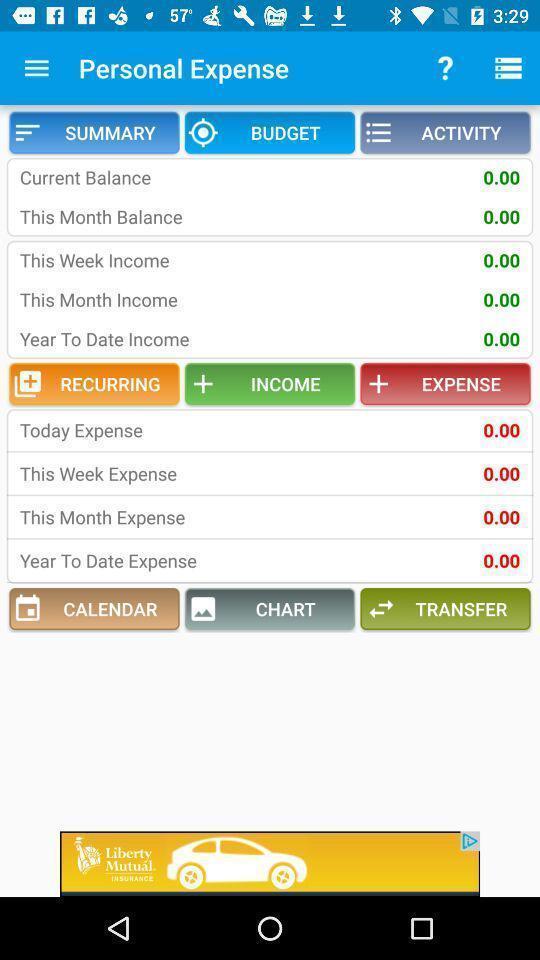Provide a detailed account of this screenshot. Screen displaying the details of personal expenses. 